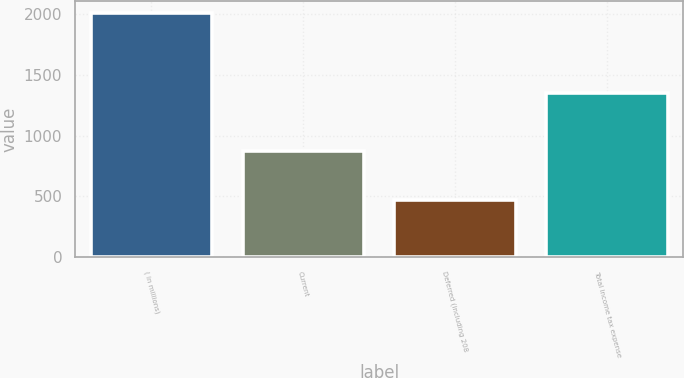Convert chart. <chart><loc_0><loc_0><loc_500><loc_500><bar_chart><fcel>( in millions)<fcel>Current<fcel>Deferred (including 208<fcel>Total income tax expense<nl><fcel>2008<fcel>874<fcel>472<fcel>1346<nl></chart> 